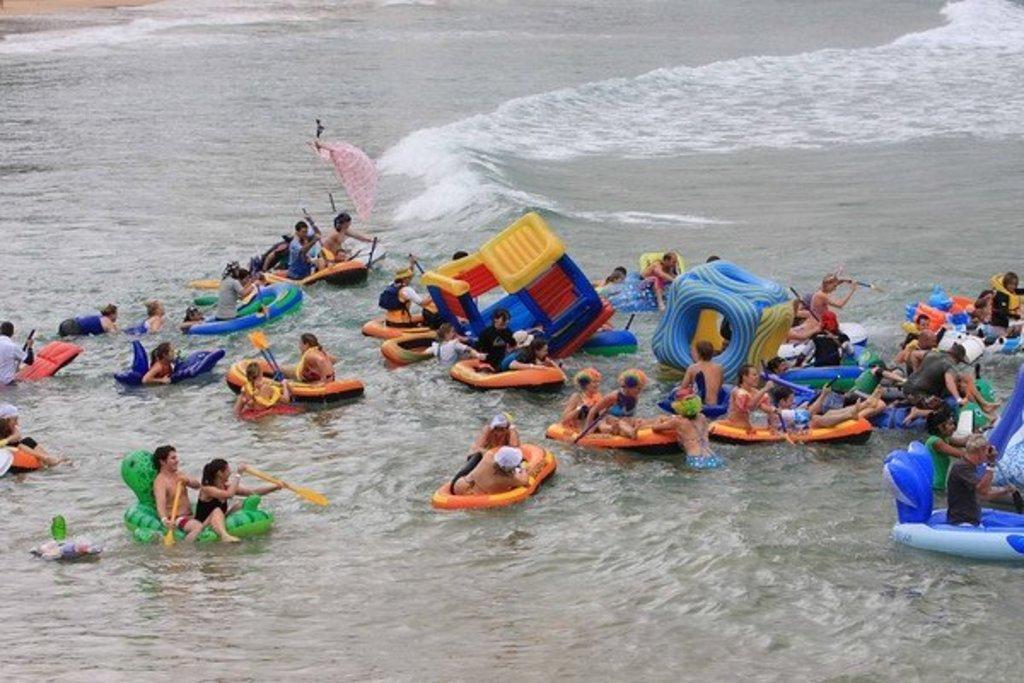Can you describe this image briefly? There is water. On the water there are many people sitting on tubes. Some are holding paddles. 